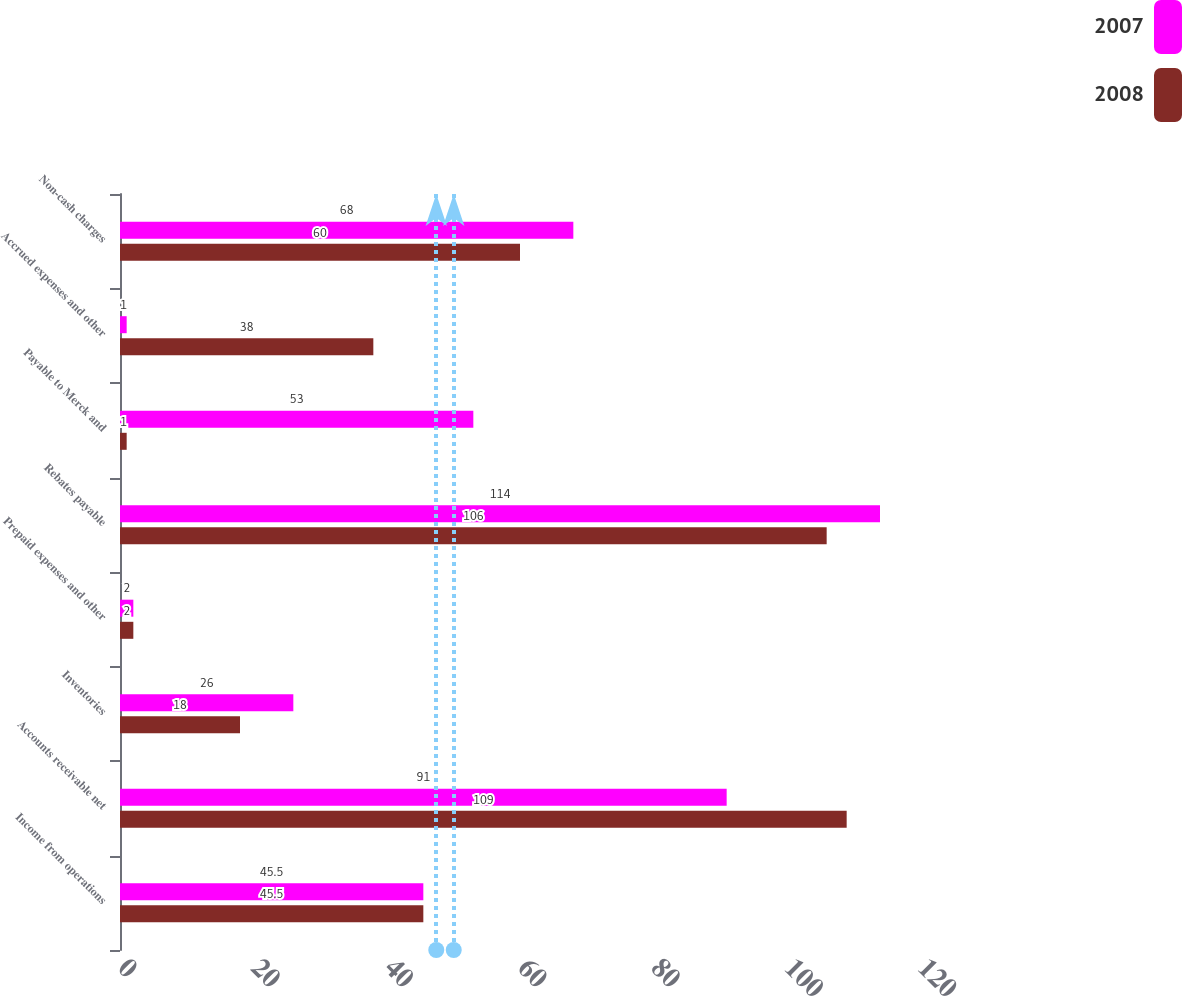Convert chart to OTSL. <chart><loc_0><loc_0><loc_500><loc_500><stacked_bar_chart><ecel><fcel>Income from operations<fcel>Accounts receivable net<fcel>Inventories<fcel>Prepaid expenses and other<fcel>Rebates payable<fcel>Payable to Merck and<fcel>Accrued expenses and other<fcel>Non-cash charges<nl><fcel>2007<fcel>45.5<fcel>91<fcel>26<fcel>2<fcel>114<fcel>53<fcel>1<fcel>68<nl><fcel>2008<fcel>45.5<fcel>109<fcel>18<fcel>2<fcel>106<fcel>1<fcel>38<fcel>60<nl></chart> 